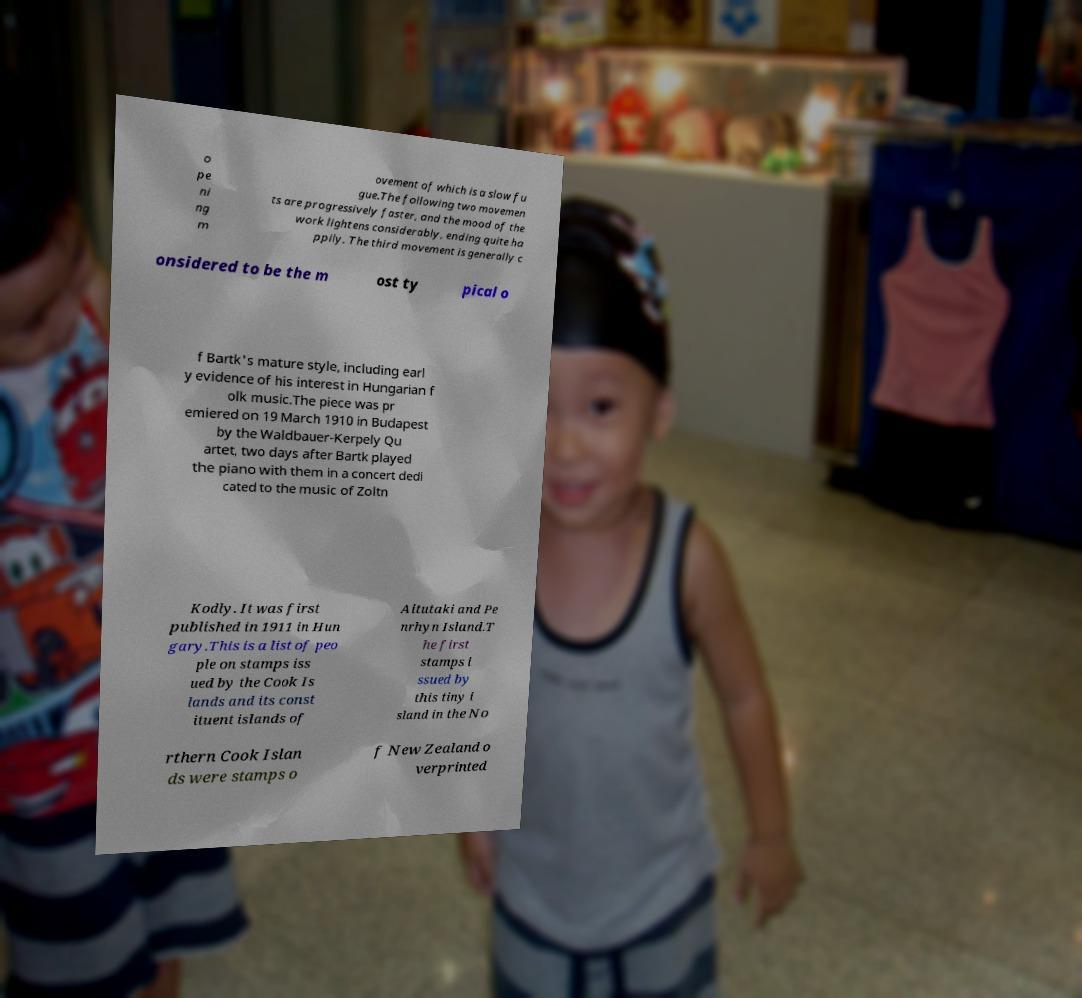Could you extract and type out the text from this image? o pe ni ng m ovement of which is a slow fu gue.The following two movemen ts are progressively faster, and the mood of the work lightens considerably, ending quite ha ppily. The third movement is generally c onsidered to be the m ost ty pical o f Bartk's mature style, including earl y evidence of his interest in Hungarian f olk music.The piece was pr emiered on 19 March 1910 in Budapest by the Waldbauer-Kerpely Qu artet, two days after Bartk played the piano with them in a concert dedi cated to the music of Zoltn Kodly. It was first published in 1911 in Hun gary.This is a list of peo ple on stamps iss ued by the Cook Is lands and its const ituent islands of Aitutaki and Pe nrhyn Island.T he first stamps i ssued by this tiny i sland in the No rthern Cook Islan ds were stamps o f New Zealand o verprinted 